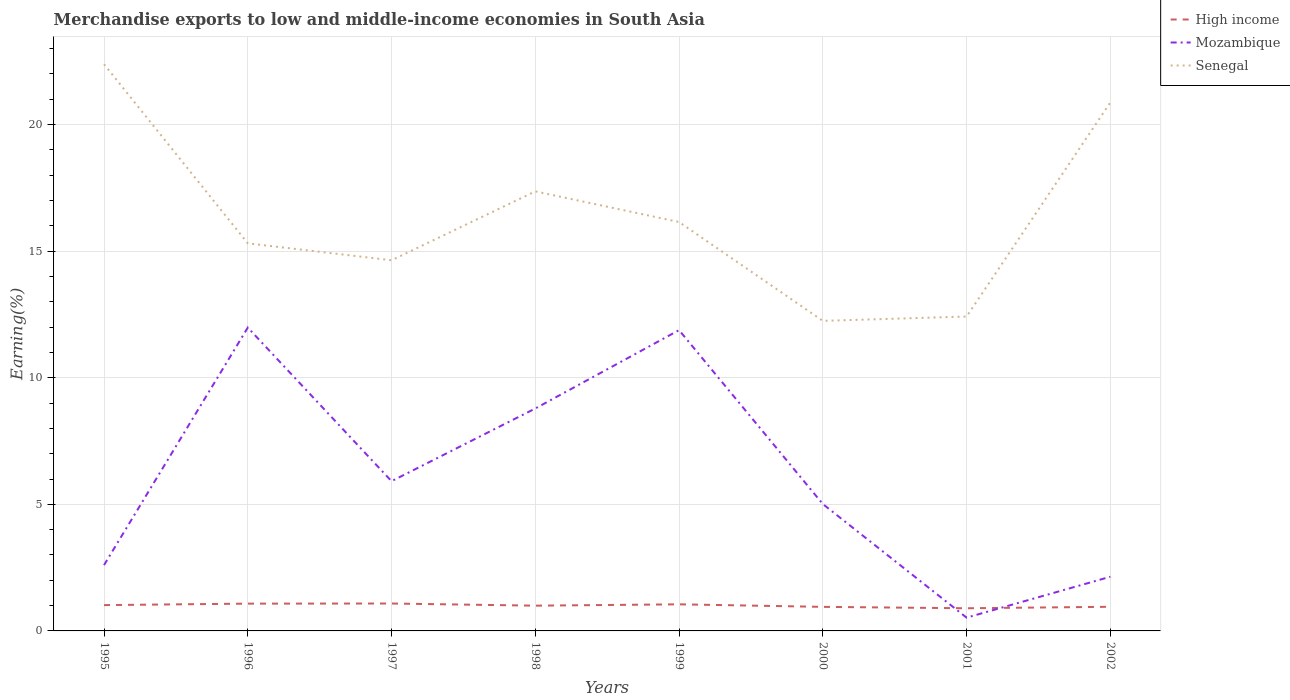Is the number of lines equal to the number of legend labels?
Keep it short and to the point. Yes. Across all years, what is the maximum percentage of amount earned from merchandise exports in High income?
Offer a terse response. 0.9. What is the total percentage of amount earned from merchandise exports in Senegal in the graph?
Offer a very short reply. 0.67. What is the difference between the highest and the second highest percentage of amount earned from merchandise exports in Senegal?
Your answer should be very brief. 10.14. Is the percentage of amount earned from merchandise exports in Mozambique strictly greater than the percentage of amount earned from merchandise exports in High income over the years?
Offer a terse response. No. How many years are there in the graph?
Provide a short and direct response. 8. What is the difference between two consecutive major ticks on the Y-axis?
Your answer should be very brief. 5. Does the graph contain any zero values?
Provide a short and direct response. No. Does the graph contain grids?
Provide a succinct answer. Yes. Where does the legend appear in the graph?
Offer a very short reply. Top right. What is the title of the graph?
Give a very brief answer. Merchandise exports to low and middle-income economies in South Asia. What is the label or title of the X-axis?
Ensure brevity in your answer.  Years. What is the label or title of the Y-axis?
Provide a short and direct response. Earning(%). What is the Earning(%) of High income in 1995?
Your answer should be very brief. 1.02. What is the Earning(%) in Mozambique in 1995?
Your response must be concise. 2.6. What is the Earning(%) of Senegal in 1995?
Provide a succinct answer. 22.38. What is the Earning(%) in High income in 1996?
Your response must be concise. 1.08. What is the Earning(%) in Mozambique in 1996?
Ensure brevity in your answer.  11.98. What is the Earning(%) in Senegal in 1996?
Provide a short and direct response. 15.31. What is the Earning(%) of High income in 1997?
Offer a very short reply. 1.08. What is the Earning(%) in Mozambique in 1997?
Keep it short and to the point. 5.91. What is the Earning(%) in Senegal in 1997?
Provide a short and direct response. 14.64. What is the Earning(%) of High income in 1998?
Ensure brevity in your answer.  1. What is the Earning(%) of Mozambique in 1998?
Offer a terse response. 8.79. What is the Earning(%) of Senegal in 1998?
Make the answer very short. 17.36. What is the Earning(%) of High income in 1999?
Offer a terse response. 1.05. What is the Earning(%) of Mozambique in 1999?
Give a very brief answer. 11.88. What is the Earning(%) in Senegal in 1999?
Offer a terse response. 16.15. What is the Earning(%) of High income in 2000?
Your answer should be very brief. 0.95. What is the Earning(%) of Mozambique in 2000?
Provide a succinct answer. 5.01. What is the Earning(%) of Senegal in 2000?
Keep it short and to the point. 12.25. What is the Earning(%) in High income in 2001?
Make the answer very short. 0.9. What is the Earning(%) in Mozambique in 2001?
Offer a terse response. 0.52. What is the Earning(%) of Senegal in 2001?
Your answer should be compact. 12.42. What is the Earning(%) of High income in 2002?
Make the answer very short. 0.95. What is the Earning(%) in Mozambique in 2002?
Ensure brevity in your answer.  2.14. What is the Earning(%) of Senegal in 2002?
Give a very brief answer. 20.88. Across all years, what is the maximum Earning(%) in High income?
Offer a very short reply. 1.08. Across all years, what is the maximum Earning(%) of Mozambique?
Ensure brevity in your answer.  11.98. Across all years, what is the maximum Earning(%) in Senegal?
Your response must be concise. 22.38. Across all years, what is the minimum Earning(%) of High income?
Your answer should be compact. 0.9. Across all years, what is the minimum Earning(%) of Mozambique?
Keep it short and to the point. 0.52. Across all years, what is the minimum Earning(%) of Senegal?
Provide a succinct answer. 12.25. What is the total Earning(%) in High income in the graph?
Your answer should be very brief. 8.03. What is the total Earning(%) of Mozambique in the graph?
Your answer should be compact. 48.84. What is the total Earning(%) in Senegal in the graph?
Offer a terse response. 131.39. What is the difference between the Earning(%) in High income in 1995 and that in 1996?
Give a very brief answer. -0.06. What is the difference between the Earning(%) of Mozambique in 1995 and that in 1996?
Provide a succinct answer. -9.38. What is the difference between the Earning(%) of Senegal in 1995 and that in 1996?
Make the answer very short. 7.07. What is the difference between the Earning(%) in High income in 1995 and that in 1997?
Your response must be concise. -0.06. What is the difference between the Earning(%) of Mozambique in 1995 and that in 1997?
Provide a short and direct response. -3.31. What is the difference between the Earning(%) of Senegal in 1995 and that in 1997?
Provide a succinct answer. 7.74. What is the difference between the Earning(%) of High income in 1995 and that in 1998?
Provide a succinct answer. 0.02. What is the difference between the Earning(%) of Mozambique in 1995 and that in 1998?
Offer a very short reply. -6.19. What is the difference between the Earning(%) of Senegal in 1995 and that in 1998?
Give a very brief answer. 5.02. What is the difference between the Earning(%) in High income in 1995 and that in 1999?
Give a very brief answer. -0.03. What is the difference between the Earning(%) of Mozambique in 1995 and that in 1999?
Make the answer very short. -9.28. What is the difference between the Earning(%) of Senegal in 1995 and that in 1999?
Ensure brevity in your answer.  6.23. What is the difference between the Earning(%) of High income in 1995 and that in 2000?
Keep it short and to the point. 0.07. What is the difference between the Earning(%) of Mozambique in 1995 and that in 2000?
Give a very brief answer. -2.41. What is the difference between the Earning(%) of Senegal in 1995 and that in 2000?
Ensure brevity in your answer.  10.14. What is the difference between the Earning(%) in High income in 1995 and that in 2001?
Ensure brevity in your answer.  0.12. What is the difference between the Earning(%) in Mozambique in 1995 and that in 2001?
Make the answer very short. 2.08. What is the difference between the Earning(%) of Senegal in 1995 and that in 2001?
Offer a very short reply. 9.97. What is the difference between the Earning(%) in High income in 1995 and that in 2002?
Offer a very short reply. 0.07. What is the difference between the Earning(%) of Mozambique in 1995 and that in 2002?
Your answer should be very brief. 0.46. What is the difference between the Earning(%) in Senegal in 1995 and that in 2002?
Your answer should be very brief. 1.51. What is the difference between the Earning(%) in High income in 1996 and that in 1997?
Keep it short and to the point. -0. What is the difference between the Earning(%) of Mozambique in 1996 and that in 1997?
Give a very brief answer. 6.07. What is the difference between the Earning(%) in Senegal in 1996 and that in 1997?
Your answer should be compact. 0.67. What is the difference between the Earning(%) in High income in 1996 and that in 1998?
Provide a succinct answer. 0.08. What is the difference between the Earning(%) of Mozambique in 1996 and that in 1998?
Provide a succinct answer. 3.2. What is the difference between the Earning(%) of Senegal in 1996 and that in 1998?
Your answer should be compact. -2.05. What is the difference between the Earning(%) of High income in 1996 and that in 1999?
Offer a very short reply. 0.03. What is the difference between the Earning(%) in Senegal in 1996 and that in 1999?
Offer a terse response. -0.84. What is the difference between the Earning(%) of High income in 1996 and that in 2000?
Give a very brief answer. 0.13. What is the difference between the Earning(%) in Mozambique in 1996 and that in 2000?
Make the answer very short. 6.97. What is the difference between the Earning(%) of Senegal in 1996 and that in 2000?
Your answer should be compact. 3.06. What is the difference between the Earning(%) of High income in 1996 and that in 2001?
Ensure brevity in your answer.  0.18. What is the difference between the Earning(%) in Mozambique in 1996 and that in 2001?
Your answer should be very brief. 11.46. What is the difference between the Earning(%) in Senegal in 1996 and that in 2001?
Your response must be concise. 2.89. What is the difference between the Earning(%) of High income in 1996 and that in 2002?
Ensure brevity in your answer.  0.12. What is the difference between the Earning(%) in Mozambique in 1996 and that in 2002?
Provide a short and direct response. 9.84. What is the difference between the Earning(%) in Senegal in 1996 and that in 2002?
Ensure brevity in your answer.  -5.57. What is the difference between the Earning(%) of High income in 1997 and that in 1998?
Give a very brief answer. 0.09. What is the difference between the Earning(%) of Mozambique in 1997 and that in 1998?
Ensure brevity in your answer.  -2.87. What is the difference between the Earning(%) of Senegal in 1997 and that in 1998?
Keep it short and to the point. -2.72. What is the difference between the Earning(%) in High income in 1997 and that in 1999?
Your response must be concise. 0.03. What is the difference between the Earning(%) of Mozambique in 1997 and that in 1999?
Your answer should be compact. -5.97. What is the difference between the Earning(%) of Senegal in 1997 and that in 1999?
Offer a terse response. -1.51. What is the difference between the Earning(%) in High income in 1997 and that in 2000?
Keep it short and to the point. 0.13. What is the difference between the Earning(%) in Mozambique in 1997 and that in 2000?
Provide a succinct answer. 0.9. What is the difference between the Earning(%) in Senegal in 1997 and that in 2000?
Provide a succinct answer. 2.39. What is the difference between the Earning(%) of High income in 1997 and that in 2001?
Your answer should be very brief. 0.19. What is the difference between the Earning(%) of Mozambique in 1997 and that in 2001?
Make the answer very short. 5.39. What is the difference between the Earning(%) of Senegal in 1997 and that in 2001?
Offer a terse response. 2.22. What is the difference between the Earning(%) of High income in 1997 and that in 2002?
Provide a succinct answer. 0.13. What is the difference between the Earning(%) of Mozambique in 1997 and that in 2002?
Your response must be concise. 3.78. What is the difference between the Earning(%) of Senegal in 1997 and that in 2002?
Your answer should be very brief. -6.23. What is the difference between the Earning(%) in High income in 1998 and that in 1999?
Your answer should be compact. -0.05. What is the difference between the Earning(%) of Mozambique in 1998 and that in 1999?
Offer a very short reply. -3.1. What is the difference between the Earning(%) in Senegal in 1998 and that in 1999?
Your answer should be compact. 1.21. What is the difference between the Earning(%) of High income in 1998 and that in 2000?
Your answer should be compact. 0.05. What is the difference between the Earning(%) of Mozambique in 1998 and that in 2000?
Keep it short and to the point. 3.77. What is the difference between the Earning(%) in Senegal in 1998 and that in 2000?
Your response must be concise. 5.11. What is the difference between the Earning(%) in High income in 1998 and that in 2001?
Your answer should be compact. 0.1. What is the difference between the Earning(%) of Mozambique in 1998 and that in 2001?
Provide a short and direct response. 8.26. What is the difference between the Earning(%) in Senegal in 1998 and that in 2001?
Provide a succinct answer. 4.94. What is the difference between the Earning(%) in High income in 1998 and that in 2002?
Provide a succinct answer. 0.04. What is the difference between the Earning(%) in Mozambique in 1998 and that in 2002?
Ensure brevity in your answer.  6.65. What is the difference between the Earning(%) of Senegal in 1998 and that in 2002?
Your response must be concise. -3.51. What is the difference between the Earning(%) in High income in 1999 and that in 2000?
Provide a short and direct response. 0.1. What is the difference between the Earning(%) of Mozambique in 1999 and that in 2000?
Provide a succinct answer. 6.87. What is the difference between the Earning(%) of Senegal in 1999 and that in 2000?
Your response must be concise. 3.9. What is the difference between the Earning(%) of High income in 1999 and that in 2001?
Offer a terse response. 0.16. What is the difference between the Earning(%) in Mozambique in 1999 and that in 2001?
Your response must be concise. 11.36. What is the difference between the Earning(%) in Senegal in 1999 and that in 2001?
Ensure brevity in your answer.  3.73. What is the difference between the Earning(%) of High income in 1999 and that in 2002?
Keep it short and to the point. 0.1. What is the difference between the Earning(%) of Mozambique in 1999 and that in 2002?
Ensure brevity in your answer.  9.74. What is the difference between the Earning(%) in Senegal in 1999 and that in 2002?
Your response must be concise. -4.72. What is the difference between the Earning(%) in High income in 2000 and that in 2001?
Give a very brief answer. 0.06. What is the difference between the Earning(%) of Mozambique in 2000 and that in 2001?
Offer a terse response. 4.49. What is the difference between the Earning(%) in Senegal in 2000 and that in 2001?
Provide a short and direct response. -0.17. What is the difference between the Earning(%) of High income in 2000 and that in 2002?
Provide a succinct answer. -0. What is the difference between the Earning(%) of Mozambique in 2000 and that in 2002?
Provide a succinct answer. 2.87. What is the difference between the Earning(%) in Senegal in 2000 and that in 2002?
Make the answer very short. -8.63. What is the difference between the Earning(%) in High income in 2001 and that in 2002?
Your answer should be very brief. -0.06. What is the difference between the Earning(%) in Mozambique in 2001 and that in 2002?
Your answer should be compact. -1.62. What is the difference between the Earning(%) in Senegal in 2001 and that in 2002?
Ensure brevity in your answer.  -8.46. What is the difference between the Earning(%) of High income in 1995 and the Earning(%) of Mozambique in 1996?
Ensure brevity in your answer.  -10.96. What is the difference between the Earning(%) of High income in 1995 and the Earning(%) of Senegal in 1996?
Ensure brevity in your answer.  -14.29. What is the difference between the Earning(%) in Mozambique in 1995 and the Earning(%) in Senegal in 1996?
Keep it short and to the point. -12.71. What is the difference between the Earning(%) of High income in 1995 and the Earning(%) of Mozambique in 1997?
Give a very brief answer. -4.89. What is the difference between the Earning(%) in High income in 1995 and the Earning(%) in Senegal in 1997?
Make the answer very short. -13.62. What is the difference between the Earning(%) of Mozambique in 1995 and the Earning(%) of Senegal in 1997?
Give a very brief answer. -12.04. What is the difference between the Earning(%) of High income in 1995 and the Earning(%) of Mozambique in 1998?
Provide a succinct answer. -7.77. What is the difference between the Earning(%) in High income in 1995 and the Earning(%) in Senegal in 1998?
Give a very brief answer. -16.34. What is the difference between the Earning(%) in Mozambique in 1995 and the Earning(%) in Senegal in 1998?
Provide a succinct answer. -14.76. What is the difference between the Earning(%) of High income in 1995 and the Earning(%) of Mozambique in 1999?
Offer a terse response. -10.86. What is the difference between the Earning(%) in High income in 1995 and the Earning(%) in Senegal in 1999?
Keep it short and to the point. -15.13. What is the difference between the Earning(%) of Mozambique in 1995 and the Earning(%) of Senegal in 1999?
Make the answer very short. -13.55. What is the difference between the Earning(%) of High income in 1995 and the Earning(%) of Mozambique in 2000?
Your answer should be compact. -3.99. What is the difference between the Earning(%) in High income in 1995 and the Earning(%) in Senegal in 2000?
Ensure brevity in your answer.  -11.23. What is the difference between the Earning(%) in Mozambique in 1995 and the Earning(%) in Senegal in 2000?
Your answer should be very brief. -9.65. What is the difference between the Earning(%) in High income in 1995 and the Earning(%) in Mozambique in 2001?
Offer a very short reply. 0.5. What is the difference between the Earning(%) of High income in 1995 and the Earning(%) of Senegal in 2001?
Give a very brief answer. -11.4. What is the difference between the Earning(%) of Mozambique in 1995 and the Earning(%) of Senegal in 2001?
Provide a short and direct response. -9.82. What is the difference between the Earning(%) of High income in 1995 and the Earning(%) of Mozambique in 2002?
Offer a very short reply. -1.12. What is the difference between the Earning(%) in High income in 1995 and the Earning(%) in Senegal in 2002?
Your response must be concise. -19.86. What is the difference between the Earning(%) of Mozambique in 1995 and the Earning(%) of Senegal in 2002?
Offer a very short reply. -18.27. What is the difference between the Earning(%) of High income in 1996 and the Earning(%) of Mozambique in 1997?
Keep it short and to the point. -4.84. What is the difference between the Earning(%) in High income in 1996 and the Earning(%) in Senegal in 1997?
Offer a very short reply. -13.56. What is the difference between the Earning(%) of Mozambique in 1996 and the Earning(%) of Senegal in 1997?
Keep it short and to the point. -2.66. What is the difference between the Earning(%) of High income in 1996 and the Earning(%) of Mozambique in 1998?
Make the answer very short. -7.71. What is the difference between the Earning(%) in High income in 1996 and the Earning(%) in Senegal in 1998?
Offer a very short reply. -16.28. What is the difference between the Earning(%) of Mozambique in 1996 and the Earning(%) of Senegal in 1998?
Make the answer very short. -5.38. What is the difference between the Earning(%) of High income in 1996 and the Earning(%) of Mozambique in 1999?
Offer a terse response. -10.8. What is the difference between the Earning(%) in High income in 1996 and the Earning(%) in Senegal in 1999?
Make the answer very short. -15.07. What is the difference between the Earning(%) in Mozambique in 1996 and the Earning(%) in Senegal in 1999?
Provide a succinct answer. -4.17. What is the difference between the Earning(%) in High income in 1996 and the Earning(%) in Mozambique in 2000?
Ensure brevity in your answer.  -3.93. What is the difference between the Earning(%) of High income in 1996 and the Earning(%) of Senegal in 2000?
Offer a very short reply. -11.17. What is the difference between the Earning(%) of Mozambique in 1996 and the Earning(%) of Senegal in 2000?
Ensure brevity in your answer.  -0.27. What is the difference between the Earning(%) of High income in 1996 and the Earning(%) of Mozambique in 2001?
Offer a terse response. 0.55. What is the difference between the Earning(%) of High income in 1996 and the Earning(%) of Senegal in 2001?
Keep it short and to the point. -11.34. What is the difference between the Earning(%) of Mozambique in 1996 and the Earning(%) of Senegal in 2001?
Offer a very short reply. -0.44. What is the difference between the Earning(%) of High income in 1996 and the Earning(%) of Mozambique in 2002?
Your answer should be compact. -1.06. What is the difference between the Earning(%) in High income in 1996 and the Earning(%) in Senegal in 2002?
Keep it short and to the point. -19.8. What is the difference between the Earning(%) of Mozambique in 1996 and the Earning(%) of Senegal in 2002?
Keep it short and to the point. -8.89. What is the difference between the Earning(%) in High income in 1997 and the Earning(%) in Mozambique in 1998?
Your answer should be compact. -7.7. What is the difference between the Earning(%) in High income in 1997 and the Earning(%) in Senegal in 1998?
Make the answer very short. -16.28. What is the difference between the Earning(%) in Mozambique in 1997 and the Earning(%) in Senegal in 1998?
Your response must be concise. -11.45. What is the difference between the Earning(%) of High income in 1997 and the Earning(%) of Mozambique in 1999?
Your response must be concise. -10.8. What is the difference between the Earning(%) in High income in 1997 and the Earning(%) in Senegal in 1999?
Keep it short and to the point. -15.07. What is the difference between the Earning(%) of Mozambique in 1997 and the Earning(%) of Senegal in 1999?
Your answer should be very brief. -10.24. What is the difference between the Earning(%) in High income in 1997 and the Earning(%) in Mozambique in 2000?
Your response must be concise. -3.93. What is the difference between the Earning(%) in High income in 1997 and the Earning(%) in Senegal in 2000?
Provide a succinct answer. -11.16. What is the difference between the Earning(%) in Mozambique in 1997 and the Earning(%) in Senegal in 2000?
Offer a terse response. -6.33. What is the difference between the Earning(%) of High income in 1997 and the Earning(%) of Mozambique in 2001?
Offer a very short reply. 0.56. What is the difference between the Earning(%) of High income in 1997 and the Earning(%) of Senegal in 2001?
Offer a terse response. -11.34. What is the difference between the Earning(%) of Mozambique in 1997 and the Earning(%) of Senegal in 2001?
Your response must be concise. -6.5. What is the difference between the Earning(%) of High income in 1997 and the Earning(%) of Mozambique in 2002?
Your answer should be very brief. -1.06. What is the difference between the Earning(%) of High income in 1997 and the Earning(%) of Senegal in 2002?
Make the answer very short. -19.79. What is the difference between the Earning(%) in Mozambique in 1997 and the Earning(%) in Senegal in 2002?
Keep it short and to the point. -14.96. What is the difference between the Earning(%) in High income in 1998 and the Earning(%) in Mozambique in 1999?
Give a very brief answer. -10.88. What is the difference between the Earning(%) in High income in 1998 and the Earning(%) in Senegal in 1999?
Keep it short and to the point. -15.15. What is the difference between the Earning(%) in Mozambique in 1998 and the Earning(%) in Senegal in 1999?
Offer a terse response. -7.37. What is the difference between the Earning(%) in High income in 1998 and the Earning(%) in Mozambique in 2000?
Provide a succinct answer. -4.01. What is the difference between the Earning(%) of High income in 1998 and the Earning(%) of Senegal in 2000?
Offer a very short reply. -11.25. What is the difference between the Earning(%) of Mozambique in 1998 and the Earning(%) of Senegal in 2000?
Ensure brevity in your answer.  -3.46. What is the difference between the Earning(%) in High income in 1998 and the Earning(%) in Mozambique in 2001?
Offer a very short reply. 0.47. What is the difference between the Earning(%) of High income in 1998 and the Earning(%) of Senegal in 2001?
Your answer should be compact. -11.42. What is the difference between the Earning(%) in Mozambique in 1998 and the Earning(%) in Senegal in 2001?
Your response must be concise. -3.63. What is the difference between the Earning(%) in High income in 1998 and the Earning(%) in Mozambique in 2002?
Your answer should be compact. -1.14. What is the difference between the Earning(%) of High income in 1998 and the Earning(%) of Senegal in 2002?
Make the answer very short. -19.88. What is the difference between the Earning(%) in Mozambique in 1998 and the Earning(%) in Senegal in 2002?
Ensure brevity in your answer.  -12.09. What is the difference between the Earning(%) of High income in 1999 and the Earning(%) of Mozambique in 2000?
Offer a terse response. -3.96. What is the difference between the Earning(%) of High income in 1999 and the Earning(%) of Senegal in 2000?
Ensure brevity in your answer.  -11.2. What is the difference between the Earning(%) in Mozambique in 1999 and the Earning(%) in Senegal in 2000?
Offer a terse response. -0.37. What is the difference between the Earning(%) in High income in 1999 and the Earning(%) in Mozambique in 2001?
Give a very brief answer. 0.53. What is the difference between the Earning(%) of High income in 1999 and the Earning(%) of Senegal in 2001?
Keep it short and to the point. -11.37. What is the difference between the Earning(%) in Mozambique in 1999 and the Earning(%) in Senegal in 2001?
Offer a very short reply. -0.54. What is the difference between the Earning(%) in High income in 1999 and the Earning(%) in Mozambique in 2002?
Make the answer very short. -1.09. What is the difference between the Earning(%) of High income in 1999 and the Earning(%) of Senegal in 2002?
Your response must be concise. -19.83. What is the difference between the Earning(%) of Mozambique in 1999 and the Earning(%) of Senegal in 2002?
Make the answer very short. -8.99. What is the difference between the Earning(%) of High income in 2000 and the Earning(%) of Mozambique in 2001?
Give a very brief answer. 0.43. What is the difference between the Earning(%) in High income in 2000 and the Earning(%) in Senegal in 2001?
Provide a short and direct response. -11.47. What is the difference between the Earning(%) of Mozambique in 2000 and the Earning(%) of Senegal in 2001?
Give a very brief answer. -7.41. What is the difference between the Earning(%) of High income in 2000 and the Earning(%) of Mozambique in 2002?
Offer a very short reply. -1.19. What is the difference between the Earning(%) of High income in 2000 and the Earning(%) of Senegal in 2002?
Offer a terse response. -19.93. What is the difference between the Earning(%) of Mozambique in 2000 and the Earning(%) of Senegal in 2002?
Ensure brevity in your answer.  -15.86. What is the difference between the Earning(%) in High income in 2001 and the Earning(%) in Mozambique in 2002?
Ensure brevity in your answer.  -1.24. What is the difference between the Earning(%) in High income in 2001 and the Earning(%) in Senegal in 2002?
Your response must be concise. -19.98. What is the difference between the Earning(%) of Mozambique in 2001 and the Earning(%) of Senegal in 2002?
Your answer should be very brief. -20.35. What is the average Earning(%) in High income per year?
Make the answer very short. 1. What is the average Earning(%) in Mozambique per year?
Provide a succinct answer. 6.11. What is the average Earning(%) in Senegal per year?
Offer a terse response. 16.42. In the year 1995, what is the difference between the Earning(%) in High income and Earning(%) in Mozambique?
Give a very brief answer. -1.58. In the year 1995, what is the difference between the Earning(%) in High income and Earning(%) in Senegal?
Make the answer very short. -21.36. In the year 1995, what is the difference between the Earning(%) in Mozambique and Earning(%) in Senegal?
Give a very brief answer. -19.78. In the year 1996, what is the difference between the Earning(%) of High income and Earning(%) of Mozambique?
Your answer should be compact. -10.9. In the year 1996, what is the difference between the Earning(%) in High income and Earning(%) in Senegal?
Your answer should be very brief. -14.23. In the year 1996, what is the difference between the Earning(%) of Mozambique and Earning(%) of Senegal?
Offer a terse response. -3.33. In the year 1997, what is the difference between the Earning(%) of High income and Earning(%) of Mozambique?
Provide a succinct answer. -4.83. In the year 1997, what is the difference between the Earning(%) of High income and Earning(%) of Senegal?
Keep it short and to the point. -13.56. In the year 1997, what is the difference between the Earning(%) in Mozambique and Earning(%) in Senegal?
Make the answer very short. -8.73. In the year 1998, what is the difference between the Earning(%) of High income and Earning(%) of Mozambique?
Your answer should be compact. -7.79. In the year 1998, what is the difference between the Earning(%) in High income and Earning(%) in Senegal?
Offer a terse response. -16.36. In the year 1998, what is the difference between the Earning(%) in Mozambique and Earning(%) in Senegal?
Offer a very short reply. -8.58. In the year 1999, what is the difference between the Earning(%) in High income and Earning(%) in Mozambique?
Your answer should be very brief. -10.83. In the year 1999, what is the difference between the Earning(%) in High income and Earning(%) in Senegal?
Your answer should be compact. -15.1. In the year 1999, what is the difference between the Earning(%) in Mozambique and Earning(%) in Senegal?
Make the answer very short. -4.27. In the year 2000, what is the difference between the Earning(%) in High income and Earning(%) in Mozambique?
Offer a terse response. -4.06. In the year 2000, what is the difference between the Earning(%) in High income and Earning(%) in Senegal?
Provide a succinct answer. -11.3. In the year 2000, what is the difference between the Earning(%) in Mozambique and Earning(%) in Senegal?
Your response must be concise. -7.24. In the year 2001, what is the difference between the Earning(%) of High income and Earning(%) of Mozambique?
Provide a succinct answer. 0.37. In the year 2001, what is the difference between the Earning(%) of High income and Earning(%) of Senegal?
Your response must be concise. -11.52. In the year 2001, what is the difference between the Earning(%) of Mozambique and Earning(%) of Senegal?
Your answer should be very brief. -11.89. In the year 2002, what is the difference between the Earning(%) of High income and Earning(%) of Mozambique?
Your response must be concise. -1.19. In the year 2002, what is the difference between the Earning(%) in High income and Earning(%) in Senegal?
Make the answer very short. -19.92. In the year 2002, what is the difference between the Earning(%) in Mozambique and Earning(%) in Senegal?
Your answer should be very brief. -18.74. What is the ratio of the Earning(%) of High income in 1995 to that in 1996?
Keep it short and to the point. 0.95. What is the ratio of the Earning(%) of Mozambique in 1995 to that in 1996?
Offer a very short reply. 0.22. What is the ratio of the Earning(%) of Senegal in 1995 to that in 1996?
Offer a very short reply. 1.46. What is the ratio of the Earning(%) of High income in 1995 to that in 1997?
Keep it short and to the point. 0.94. What is the ratio of the Earning(%) in Mozambique in 1995 to that in 1997?
Your answer should be compact. 0.44. What is the ratio of the Earning(%) of Senegal in 1995 to that in 1997?
Your answer should be very brief. 1.53. What is the ratio of the Earning(%) in High income in 1995 to that in 1998?
Keep it short and to the point. 1.02. What is the ratio of the Earning(%) of Mozambique in 1995 to that in 1998?
Offer a very short reply. 0.3. What is the ratio of the Earning(%) in Senegal in 1995 to that in 1998?
Provide a succinct answer. 1.29. What is the ratio of the Earning(%) of High income in 1995 to that in 1999?
Your response must be concise. 0.97. What is the ratio of the Earning(%) in Mozambique in 1995 to that in 1999?
Provide a short and direct response. 0.22. What is the ratio of the Earning(%) in Senegal in 1995 to that in 1999?
Give a very brief answer. 1.39. What is the ratio of the Earning(%) in High income in 1995 to that in 2000?
Keep it short and to the point. 1.07. What is the ratio of the Earning(%) of Mozambique in 1995 to that in 2000?
Offer a terse response. 0.52. What is the ratio of the Earning(%) in Senegal in 1995 to that in 2000?
Keep it short and to the point. 1.83. What is the ratio of the Earning(%) in High income in 1995 to that in 2001?
Give a very brief answer. 1.14. What is the ratio of the Earning(%) in Mozambique in 1995 to that in 2001?
Your answer should be compact. 4.96. What is the ratio of the Earning(%) of Senegal in 1995 to that in 2001?
Ensure brevity in your answer.  1.8. What is the ratio of the Earning(%) of High income in 1995 to that in 2002?
Your answer should be very brief. 1.07. What is the ratio of the Earning(%) in Mozambique in 1995 to that in 2002?
Provide a short and direct response. 1.22. What is the ratio of the Earning(%) in Senegal in 1995 to that in 2002?
Your answer should be very brief. 1.07. What is the ratio of the Earning(%) in High income in 1996 to that in 1997?
Ensure brevity in your answer.  1. What is the ratio of the Earning(%) in Mozambique in 1996 to that in 1997?
Offer a terse response. 2.03. What is the ratio of the Earning(%) in Senegal in 1996 to that in 1997?
Offer a very short reply. 1.05. What is the ratio of the Earning(%) of High income in 1996 to that in 1998?
Offer a terse response. 1.08. What is the ratio of the Earning(%) in Mozambique in 1996 to that in 1998?
Ensure brevity in your answer.  1.36. What is the ratio of the Earning(%) of Senegal in 1996 to that in 1998?
Your answer should be very brief. 0.88. What is the ratio of the Earning(%) in High income in 1996 to that in 1999?
Your response must be concise. 1.03. What is the ratio of the Earning(%) in Mozambique in 1996 to that in 1999?
Keep it short and to the point. 1.01. What is the ratio of the Earning(%) in Senegal in 1996 to that in 1999?
Offer a very short reply. 0.95. What is the ratio of the Earning(%) of High income in 1996 to that in 2000?
Ensure brevity in your answer.  1.13. What is the ratio of the Earning(%) of Mozambique in 1996 to that in 2000?
Ensure brevity in your answer.  2.39. What is the ratio of the Earning(%) in Senegal in 1996 to that in 2000?
Offer a very short reply. 1.25. What is the ratio of the Earning(%) in High income in 1996 to that in 2001?
Your answer should be compact. 1.2. What is the ratio of the Earning(%) in Mozambique in 1996 to that in 2001?
Offer a terse response. 22.84. What is the ratio of the Earning(%) in Senegal in 1996 to that in 2001?
Your answer should be compact. 1.23. What is the ratio of the Earning(%) in High income in 1996 to that in 2002?
Your response must be concise. 1.13. What is the ratio of the Earning(%) in Mozambique in 1996 to that in 2002?
Ensure brevity in your answer.  5.6. What is the ratio of the Earning(%) in Senegal in 1996 to that in 2002?
Your response must be concise. 0.73. What is the ratio of the Earning(%) of High income in 1997 to that in 1998?
Your answer should be very brief. 1.09. What is the ratio of the Earning(%) of Mozambique in 1997 to that in 1998?
Keep it short and to the point. 0.67. What is the ratio of the Earning(%) in Senegal in 1997 to that in 1998?
Your answer should be very brief. 0.84. What is the ratio of the Earning(%) of High income in 1997 to that in 1999?
Offer a terse response. 1.03. What is the ratio of the Earning(%) in Mozambique in 1997 to that in 1999?
Your response must be concise. 0.5. What is the ratio of the Earning(%) in Senegal in 1997 to that in 1999?
Provide a succinct answer. 0.91. What is the ratio of the Earning(%) of High income in 1997 to that in 2000?
Give a very brief answer. 1.14. What is the ratio of the Earning(%) of Mozambique in 1997 to that in 2000?
Offer a very short reply. 1.18. What is the ratio of the Earning(%) in Senegal in 1997 to that in 2000?
Provide a short and direct response. 1.2. What is the ratio of the Earning(%) in High income in 1997 to that in 2001?
Your response must be concise. 1.21. What is the ratio of the Earning(%) of Mozambique in 1997 to that in 2001?
Ensure brevity in your answer.  11.27. What is the ratio of the Earning(%) of Senegal in 1997 to that in 2001?
Keep it short and to the point. 1.18. What is the ratio of the Earning(%) of High income in 1997 to that in 2002?
Offer a terse response. 1.14. What is the ratio of the Earning(%) in Mozambique in 1997 to that in 2002?
Your answer should be very brief. 2.76. What is the ratio of the Earning(%) of Senegal in 1997 to that in 2002?
Provide a short and direct response. 0.7. What is the ratio of the Earning(%) in High income in 1998 to that in 1999?
Give a very brief answer. 0.95. What is the ratio of the Earning(%) of Mozambique in 1998 to that in 1999?
Ensure brevity in your answer.  0.74. What is the ratio of the Earning(%) of Senegal in 1998 to that in 1999?
Your answer should be very brief. 1.07. What is the ratio of the Earning(%) of Mozambique in 1998 to that in 2000?
Provide a succinct answer. 1.75. What is the ratio of the Earning(%) in Senegal in 1998 to that in 2000?
Offer a very short reply. 1.42. What is the ratio of the Earning(%) of High income in 1998 to that in 2001?
Offer a very short reply. 1.11. What is the ratio of the Earning(%) of Mozambique in 1998 to that in 2001?
Your answer should be very brief. 16.75. What is the ratio of the Earning(%) in Senegal in 1998 to that in 2001?
Offer a terse response. 1.4. What is the ratio of the Earning(%) of High income in 1998 to that in 2002?
Provide a succinct answer. 1.05. What is the ratio of the Earning(%) in Mozambique in 1998 to that in 2002?
Make the answer very short. 4.11. What is the ratio of the Earning(%) in Senegal in 1998 to that in 2002?
Your answer should be very brief. 0.83. What is the ratio of the Earning(%) in High income in 1999 to that in 2000?
Ensure brevity in your answer.  1.11. What is the ratio of the Earning(%) in Mozambique in 1999 to that in 2000?
Provide a short and direct response. 2.37. What is the ratio of the Earning(%) of Senegal in 1999 to that in 2000?
Offer a terse response. 1.32. What is the ratio of the Earning(%) of High income in 1999 to that in 2001?
Your answer should be very brief. 1.17. What is the ratio of the Earning(%) of Mozambique in 1999 to that in 2001?
Provide a succinct answer. 22.65. What is the ratio of the Earning(%) of Senegal in 1999 to that in 2001?
Ensure brevity in your answer.  1.3. What is the ratio of the Earning(%) in High income in 1999 to that in 2002?
Your response must be concise. 1.1. What is the ratio of the Earning(%) of Mozambique in 1999 to that in 2002?
Provide a succinct answer. 5.55. What is the ratio of the Earning(%) in Senegal in 1999 to that in 2002?
Make the answer very short. 0.77. What is the ratio of the Earning(%) in High income in 2000 to that in 2001?
Offer a terse response. 1.06. What is the ratio of the Earning(%) of Mozambique in 2000 to that in 2001?
Make the answer very short. 9.55. What is the ratio of the Earning(%) of Senegal in 2000 to that in 2001?
Provide a short and direct response. 0.99. What is the ratio of the Earning(%) in High income in 2000 to that in 2002?
Ensure brevity in your answer.  1. What is the ratio of the Earning(%) of Mozambique in 2000 to that in 2002?
Provide a short and direct response. 2.34. What is the ratio of the Earning(%) in Senegal in 2000 to that in 2002?
Offer a terse response. 0.59. What is the ratio of the Earning(%) in High income in 2001 to that in 2002?
Your answer should be very brief. 0.94. What is the ratio of the Earning(%) of Mozambique in 2001 to that in 2002?
Your response must be concise. 0.25. What is the ratio of the Earning(%) in Senegal in 2001 to that in 2002?
Your answer should be very brief. 0.59. What is the difference between the highest and the second highest Earning(%) of High income?
Offer a terse response. 0. What is the difference between the highest and the second highest Earning(%) of Senegal?
Your answer should be very brief. 1.51. What is the difference between the highest and the lowest Earning(%) of High income?
Offer a very short reply. 0.19. What is the difference between the highest and the lowest Earning(%) in Mozambique?
Make the answer very short. 11.46. What is the difference between the highest and the lowest Earning(%) in Senegal?
Provide a short and direct response. 10.14. 